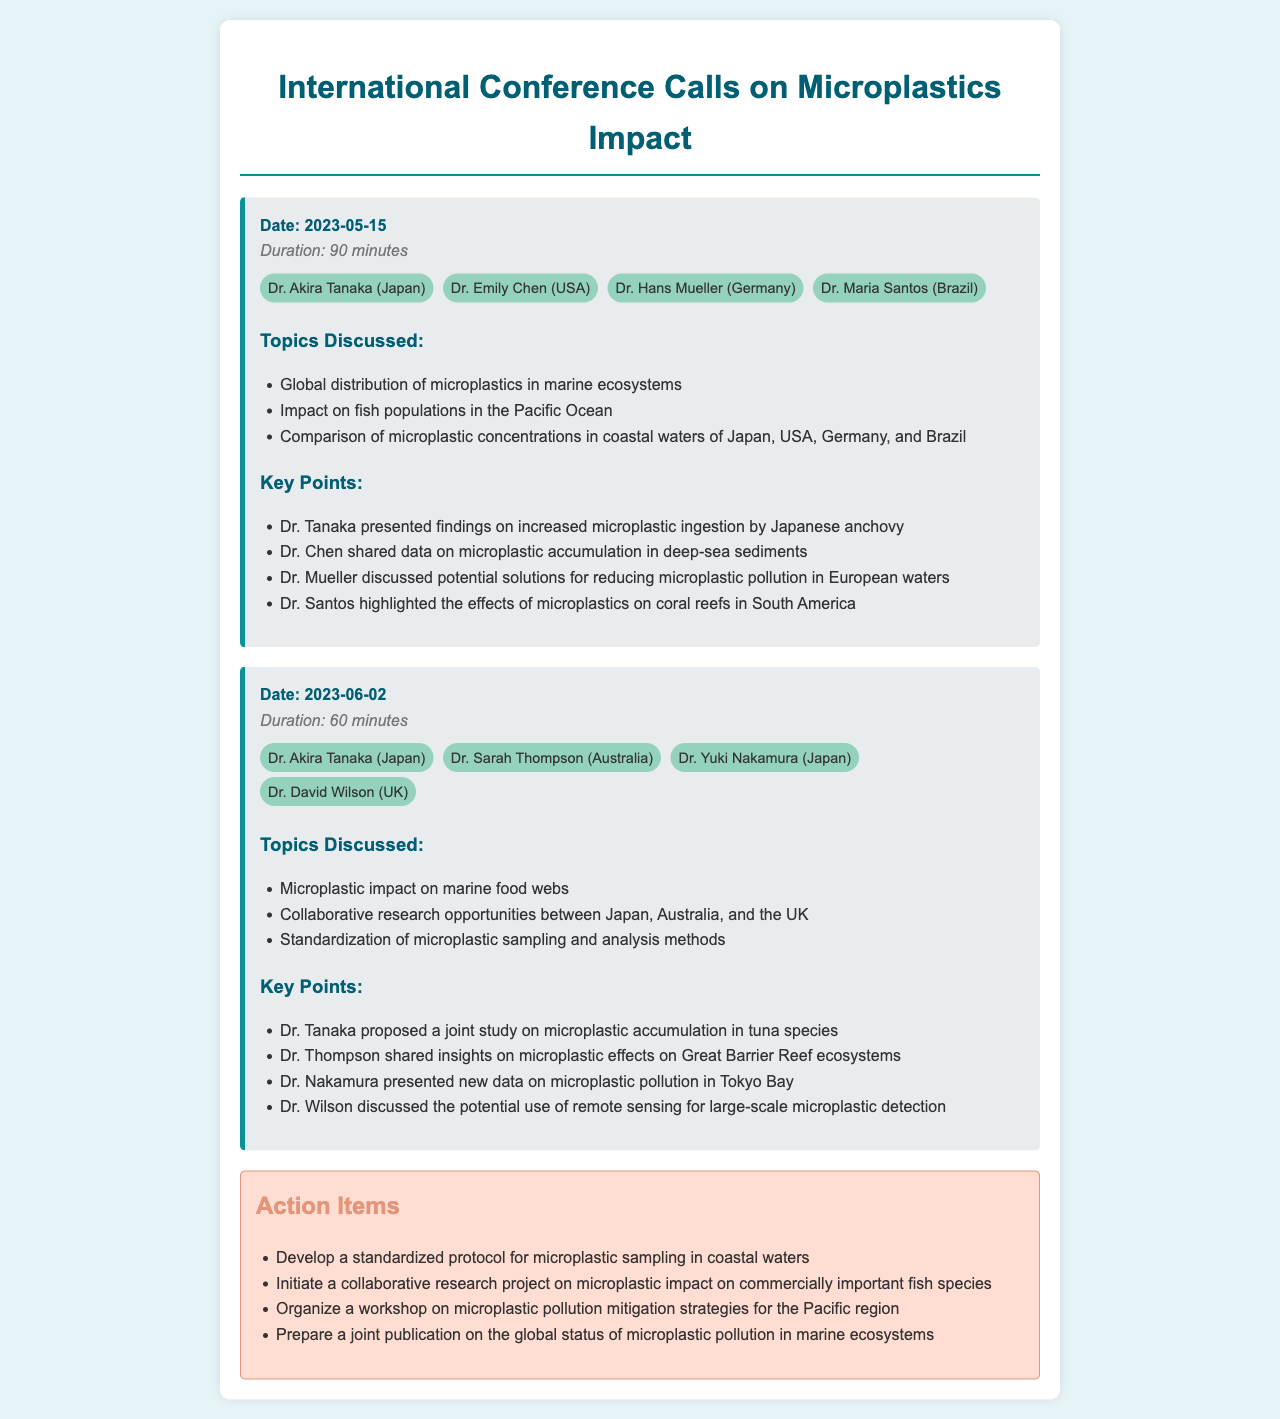what was the duration of the call on 2023-05-15? The duration of the call on this date is mentioned in the call record section.
Answer: 90 minutes who presented findings on increased microplastic ingestion? This information is found in the key points of the first call record.
Answer: Dr. Tanaka which countries were involved in the collaborative research opportunities discussed on 2023-06-02? This information is gathered from the topics discussed in the second call record.
Answer: Japan, Australia, and the UK what was one of the proposed action items? Action items are listed at the end of the document, and this information is specified there.
Answer: Develop a standardized protocol for microplastic sampling in coastal waters which participant discussed the effects of microplastics on coral reefs? This information is included in the key points of the first call record.
Answer: Dr. Santos 